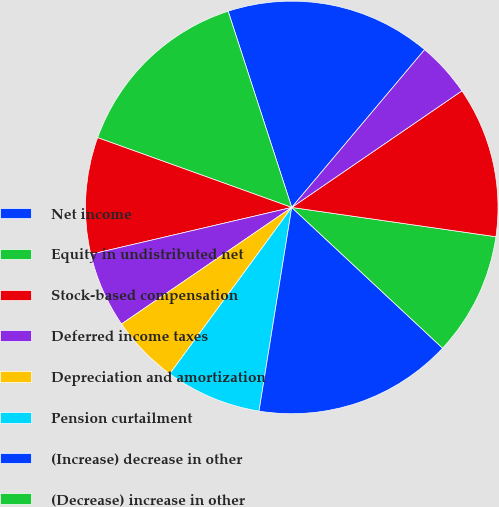Convert chart. <chart><loc_0><loc_0><loc_500><loc_500><pie_chart><fcel>Net income<fcel>Equity in undistributed net<fcel>Stock-based compensation<fcel>Deferred income taxes<fcel>Depreciation and amortization<fcel>Pension curtailment<fcel>(Increase) decrease in other<fcel>(Decrease) increase in other<fcel>Net cash provided by (used<fcel>(Increase) decrease in<nl><fcel>16.13%<fcel>14.52%<fcel>9.14%<fcel>5.91%<fcel>5.38%<fcel>7.53%<fcel>15.59%<fcel>9.68%<fcel>11.83%<fcel>4.3%<nl></chart> 